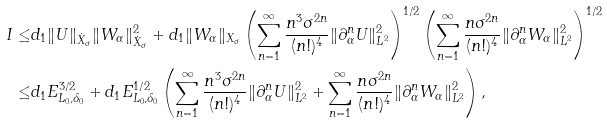<formula> <loc_0><loc_0><loc_500><loc_500>I \leq & d _ { 1 } \| U \| _ { \dot { X } _ { \sigma } } \| W _ { \alpha } \| _ { \dot { X } _ { \sigma } } ^ { 2 } + d _ { 1 } \| W _ { \alpha } \| _ { X _ { \sigma } } \left ( \sum _ { n = 1 } ^ { \infty } \frac { n ^ { 3 } \sigma ^ { 2 n } } { ( n ! ) ^ { 4 } } \| \partial _ { \alpha } ^ { n } U \| _ { L ^ { 2 } } ^ { 2 } \right ) ^ { 1 / 2 } \left ( \sum _ { n = 1 } ^ { \infty } \frac { n \sigma ^ { 2 n } } { ( n ! ) ^ { 4 } } \| \partial _ { \alpha } ^ { n } W _ { \alpha } \| _ { L ^ { 2 } } ^ { 2 } \right ) ^ { 1 / 2 } \\ \leq & d _ { 1 } E _ { L _ { 0 } , \delta _ { 0 } } ^ { 3 / 2 } + d _ { 1 } E _ { L _ { 0 } , \delta _ { 0 } } ^ { 1 / 2 } \left ( \sum _ { n = 1 } ^ { \infty } \frac { n ^ { 3 } \sigma ^ { 2 n } } { ( n ! ) ^ { 4 } } \| \partial _ { \alpha } ^ { n } U \| _ { L ^ { 2 } } ^ { 2 } + \sum _ { n = 1 } ^ { \infty } \frac { n \sigma ^ { 2 n } } { ( n ! ) ^ { 4 } } \| \partial _ { \alpha } ^ { n } W _ { \alpha } \| _ { L ^ { 2 } } ^ { 2 } \right ) ,</formula> 